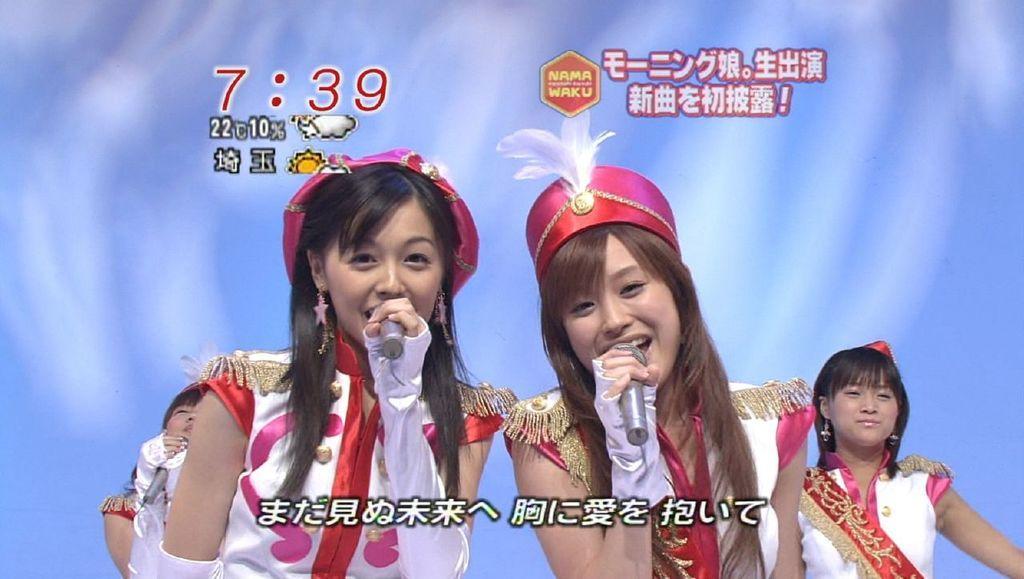How would you summarize this image in a sentence or two? Background portion of the picture is in blue and white color. In this picture we can see four women and three women are holding microphones in their hands. We can see watermarks. 